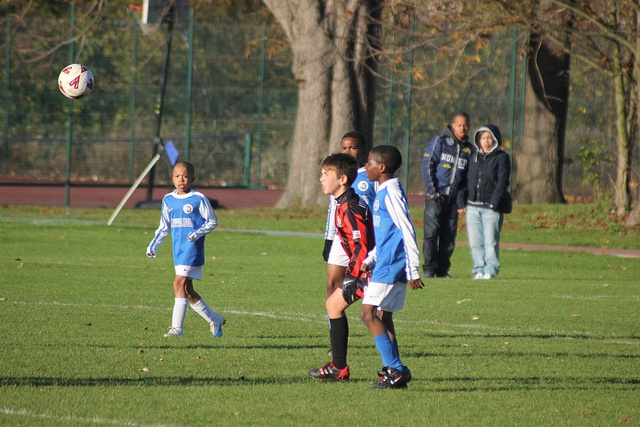Describe the objects in this image and their specific colors. I can see people in black, white, lightblue, and gray tones, people in black, tan, maroon, and gray tones, people in black, lightgray, lightblue, and gray tones, people in black and gray tones, and people in black, darkgray, lightgray, and purple tones in this image. 